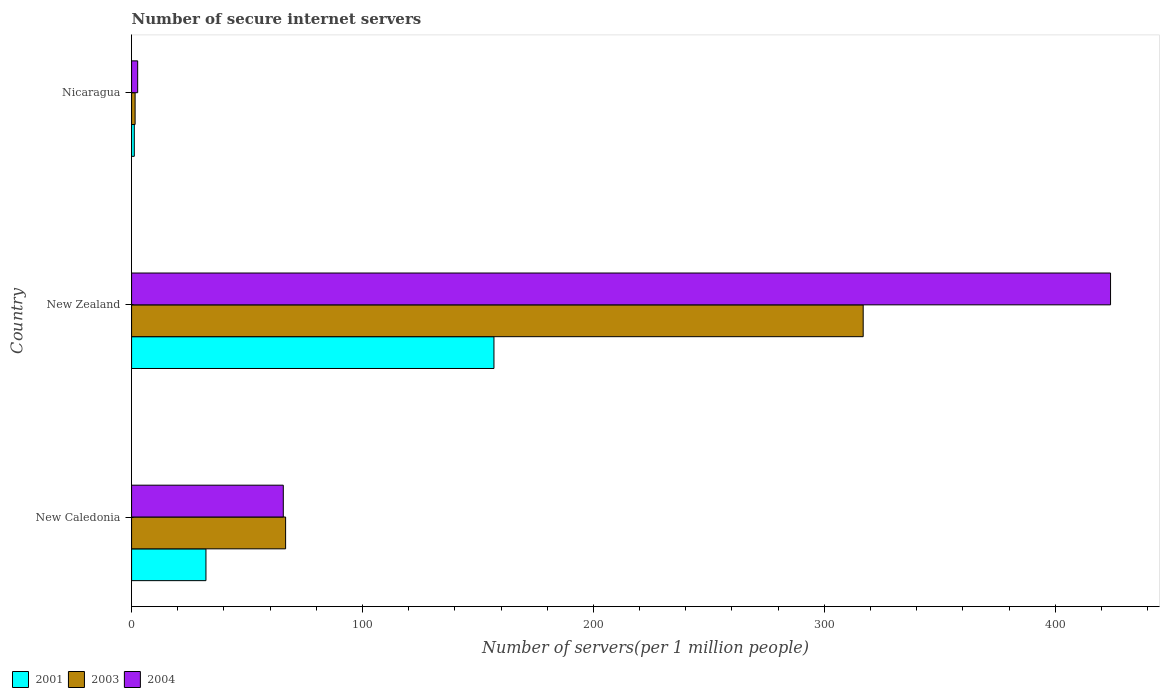How many bars are there on the 2nd tick from the top?
Offer a terse response. 3. How many bars are there on the 2nd tick from the bottom?
Your answer should be compact. 3. What is the label of the 1st group of bars from the top?
Your answer should be compact. Nicaragua. In how many cases, is the number of bars for a given country not equal to the number of legend labels?
Offer a terse response. 0. What is the number of secure internet servers in 2001 in New Caledonia?
Your response must be concise. 32.21. Across all countries, what is the maximum number of secure internet servers in 2001?
Your answer should be compact. 156.94. Across all countries, what is the minimum number of secure internet servers in 2003?
Offer a terse response. 1.53. In which country was the number of secure internet servers in 2003 maximum?
Your answer should be very brief. New Zealand. In which country was the number of secure internet servers in 2001 minimum?
Offer a very short reply. Nicaragua. What is the total number of secure internet servers in 2004 in the graph?
Give a very brief answer. 492.32. What is the difference between the number of secure internet servers in 2001 in New Caledonia and that in New Zealand?
Ensure brevity in your answer.  -124.73. What is the difference between the number of secure internet servers in 2001 in New Zealand and the number of secure internet servers in 2004 in New Caledonia?
Offer a very short reply. 91.23. What is the average number of secure internet servers in 2004 per country?
Make the answer very short. 164.11. What is the difference between the number of secure internet servers in 2001 and number of secure internet servers in 2003 in Nicaragua?
Your answer should be compact. -0.35. In how many countries, is the number of secure internet servers in 2003 greater than 60 ?
Your response must be concise. 2. What is the ratio of the number of secure internet servers in 2003 in New Caledonia to that in New Zealand?
Offer a very short reply. 0.21. Is the number of secure internet servers in 2001 in New Zealand less than that in Nicaragua?
Keep it short and to the point. No. What is the difference between the highest and the second highest number of secure internet servers in 2004?
Provide a short and direct response. 358.27. What is the difference between the highest and the lowest number of secure internet servers in 2001?
Offer a terse response. 155.76. Is the sum of the number of secure internet servers in 2003 in New Caledonia and Nicaragua greater than the maximum number of secure internet servers in 2004 across all countries?
Keep it short and to the point. No. Is it the case that in every country, the sum of the number of secure internet servers in 2003 and number of secure internet servers in 2004 is greater than the number of secure internet servers in 2001?
Your response must be concise. Yes. What is the difference between two consecutive major ticks on the X-axis?
Your response must be concise. 100. How are the legend labels stacked?
Ensure brevity in your answer.  Horizontal. What is the title of the graph?
Make the answer very short. Number of secure internet servers. What is the label or title of the X-axis?
Provide a succinct answer. Number of servers(per 1 million people). What is the Number of servers(per 1 million people) in 2001 in New Caledonia?
Provide a succinct answer. 32.21. What is the Number of servers(per 1 million people) in 2003 in New Caledonia?
Make the answer very short. 66.71. What is the Number of servers(per 1 million people) in 2004 in New Caledonia?
Your response must be concise. 65.7. What is the Number of servers(per 1 million people) of 2001 in New Zealand?
Provide a short and direct response. 156.94. What is the Number of servers(per 1 million people) of 2003 in New Zealand?
Give a very brief answer. 316.85. What is the Number of servers(per 1 million people) in 2004 in New Zealand?
Keep it short and to the point. 423.98. What is the Number of servers(per 1 million people) of 2001 in Nicaragua?
Offer a very short reply. 1.18. What is the Number of servers(per 1 million people) in 2003 in Nicaragua?
Make the answer very short. 1.53. What is the Number of servers(per 1 million people) of 2004 in Nicaragua?
Provide a succinct answer. 2.64. Across all countries, what is the maximum Number of servers(per 1 million people) of 2001?
Keep it short and to the point. 156.94. Across all countries, what is the maximum Number of servers(per 1 million people) of 2003?
Offer a very short reply. 316.85. Across all countries, what is the maximum Number of servers(per 1 million people) in 2004?
Offer a very short reply. 423.98. Across all countries, what is the minimum Number of servers(per 1 million people) in 2001?
Offer a very short reply. 1.18. Across all countries, what is the minimum Number of servers(per 1 million people) of 2003?
Provide a short and direct response. 1.53. Across all countries, what is the minimum Number of servers(per 1 million people) in 2004?
Your answer should be compact. 2.64. What is the total Number of servers(per 1 million people) in 2001 in the graph?
Provide a short and direct response. 190.32. What is the total Number of servers(per 1 million people) of 2003 in the graph?
Your answer should be compact. 385.08. What is the total Number of servers(per 1 million people) of 2004 in the graph?
Offer a terse response. 492.32. What is the difference between the Number of servers(per 1 million people) of 2001 in New Caledonia and that in New Zealand?
Provide a short and direct response. -124.73. What is the difference between the Number of servers(per 1 million people) in 2003 in New Caledonia and that in New Zealand?
Your response must be concise. -250.14. What is the difference between the Number of servers(per 1 million people) of 2004 in New Caledonia and that in New Zealand?
Make the answer very short. -358.27. What is the difference between the Number of servers(per 1 million people) of 2001 in New Caledonia and that in Nicaragua?
Offer a terse response. 31.03. What is the difference between the Number of servers(per 1 million people) in 2003 in New Caledonia and that in Nicaragua?
Ensure brevity in your answer.  65.18. What is the difference between the Number of servers(per 1 million people) in 2004 in New Caledonia and that in Nicaragua?
Your answer should be very brief. 63.07. What is the difference between the Number of servers(per 1 million people) of 2001 in New Zealand and that in Nicaragua?
Offer a terse response. 155.76. What is the difference between the Number of servers(per 1 million people) in 2003 in New Zealand and that in Nicaragua?
Your answer should be very brief. 315.32. What is the difference between the Number of servers(per 1 million people) of 2004 in New Zealand and that in Nicaragua?
Offer a very short reply. 421.34. What is the difference between the Number of servers(per 1 million people) in 2001 in New Caledonia and the Number of servers(per 1 million people) in 2003 in New Zealand?
Provide a succinct answer. -284.64. What is the difference between the Number of servers(per 1 million people) in 2001 in New Caledonia and the Number of servers(per 1 million people) in 2004 in New Zealand?
Make the answer very short. -391.77. What is the difference between the Number of servers(per 1 million people) of 2003 in New Caledonia and the Number of servers(per 1 million people) of 2004 in New Zealand?
Provide a short and direct response. -357.27. What is the difference between the Number of servers(per 1 million people) of 2001 in New Caledonia and the Number of servers(per 1 million people) of 2003 in Nicaragua?
Your answer should be very brief. 30.68. What is the difference between the Number of servers(per 1 million people) in 2001 in New Caledonia and the Number of servers(per 1 million people) in 2004 in Nicaragua?
Provide a short and direct response. 29.57. What is the difference between the Number of servers(per 1 million people) in 2003 in New Caledonia and the Number of servers(per 1 million people) in 2004 in Nicaragua?
Keep it short and to the point. 64.07. What is the difference between the Number of servers(per 1 million people) in 2001 in New Zealand and the Number of servers(per 1 million people) in 2003 in Nicaragua?
Give a very brief answer. 155.41. What is the difference between the Number of servers(per 1 million people) in 2001 in New Zealand and the Number of servers(per 1 million people) in 2004 in Nicaragua?
Your response must be concise. 154.3. What is the difference between the Number of servers(per 1 million people) in 2003 in New Zealand and the Number of servers(per 1 million people) in 2004 in Nicaragua?
Your answer should be very brief. 314.21. What is the average Number of servers(per 1 million people) in 2001 per country?
Ensure brevity in your answer.  63.44. What is the average Number of servers(per 1 million people) of 2003 per country?
Your answer should be very brief. 128.36. What is the average Number of servers(per 1 million people) of 2004 per country?
Keep it short and to the point. 164.11. What is the difference between the Number of servers(per 1 million people) in 2001 and Number of servers(per 1 million people) in 2003 in New Caledonia?
Offer a very short reply. -34.5. What is the difference between the Number of servers(per 1 million people) in 2001 and Number of servers(per 1 million people) in 2004 in New Caledonia?
Offer a terse response. -33.49. What is the difference between the Number of servers(per 1 million people) in 2001 and Number of servers(per 1 million people) in 2003 in New Zealand?
Offer a terse response. -159.91. What is the difference between the Number of servers(per 1 million people) of 2001 and Number of servers(per 1 million people) of 2004 in New Zealand?
Offer a very short reply. -267.04. What is the difference between the Number of servers(per 1 million people) in 2003 and Number of servers(per 1 million people) in 2004 in New Zealand?
Offer a very short reply. -107.13. What is the difference between the Number of servers(per 1 million people) in 2001 and Number of servers(per 1 million people) in 2003 in Nicaragua?
Your answer should be compact. -0.35. What is the difference between the Number of servers(per 1 million people) of 2001 and Number of servers(per 1 million people) of 2004 in Nicaragua?
Ensure brevity in your answer.  -1.46. What is the difference between the Number of servers(per 1 million people) of 2003 and Number of servers(per 1 million people) of 2004 in Nicaragua?
Your answer should be compact. -1.11. What is the ratio of the Number of servers(per 1 million people) in 2001 in New Caledonia to that in New Zealand?
Your answer should be very brief. 0.21. What is the ratio of the Number of servers(per 1 million people) of 2003 in New Caledonia to that in New Zealand?
Offer a terse response. 0.21. What is the ratio of the Number of servers(per 1 million people) in 2004 in New Caledonia to that in New Zealand?
Your answer should be very brief. 0.15. What is the ratio of the Number of servers(per 1 million people) in 2001 in New Caledonia to that in Nicaragua?
Offer a terse response. 27.38. What is the ratio of the Number of servers(per 1 million people) in 2003 in New Caledonia to that in Nicaragua?
Offer a very short reply. 43.7. What is the ratio of the Number of servers(per 1 million people) of 2004 in New Caledonia to that in Nicaragua?
Your answer should be compact. 24.92. What is the ratio of the Number of servers(per 1 million people) in 2001 in New Zealand to that in Nicaragua?
Provide a short and direct response. 133.42. What is the ratio of the Number of servers(per 1 million people) of 2003 in New Zealand to that in Nicaragua?
Your response must be concise. 207.57. What is the ratio of the Number of servers(per 1 million people) in 2004 in New Zealand to that in Nicaragua?
Provide a short and direct response. 160.8. What is the difference between the highest and the second highest Number of servers(per 1 million people) of 2001?
Your answer should be compact. 124.73. What is the difference between the highest and the second highest Number of servers(per 1 million people) of 2003?
Offer a very short reply. 250.14. What is the difference between the highest and the second highest Number of servers(per 1 million people) of 2004?
Provide a succinct answer. 358.27. What is the difference between the highest and the lowest Number of servers(per 1 million people) in 2001?
Your answer should be compact. 155.76. What is the difference between the highest and the lowest Number of servers(per 1 million people) of 2003?
Ensure brevity in your answer.  315.32. What is the difference between the highest and the lowest Number of servers(per 1 million people) in 2004?
Your response must be concise. 421.34. 